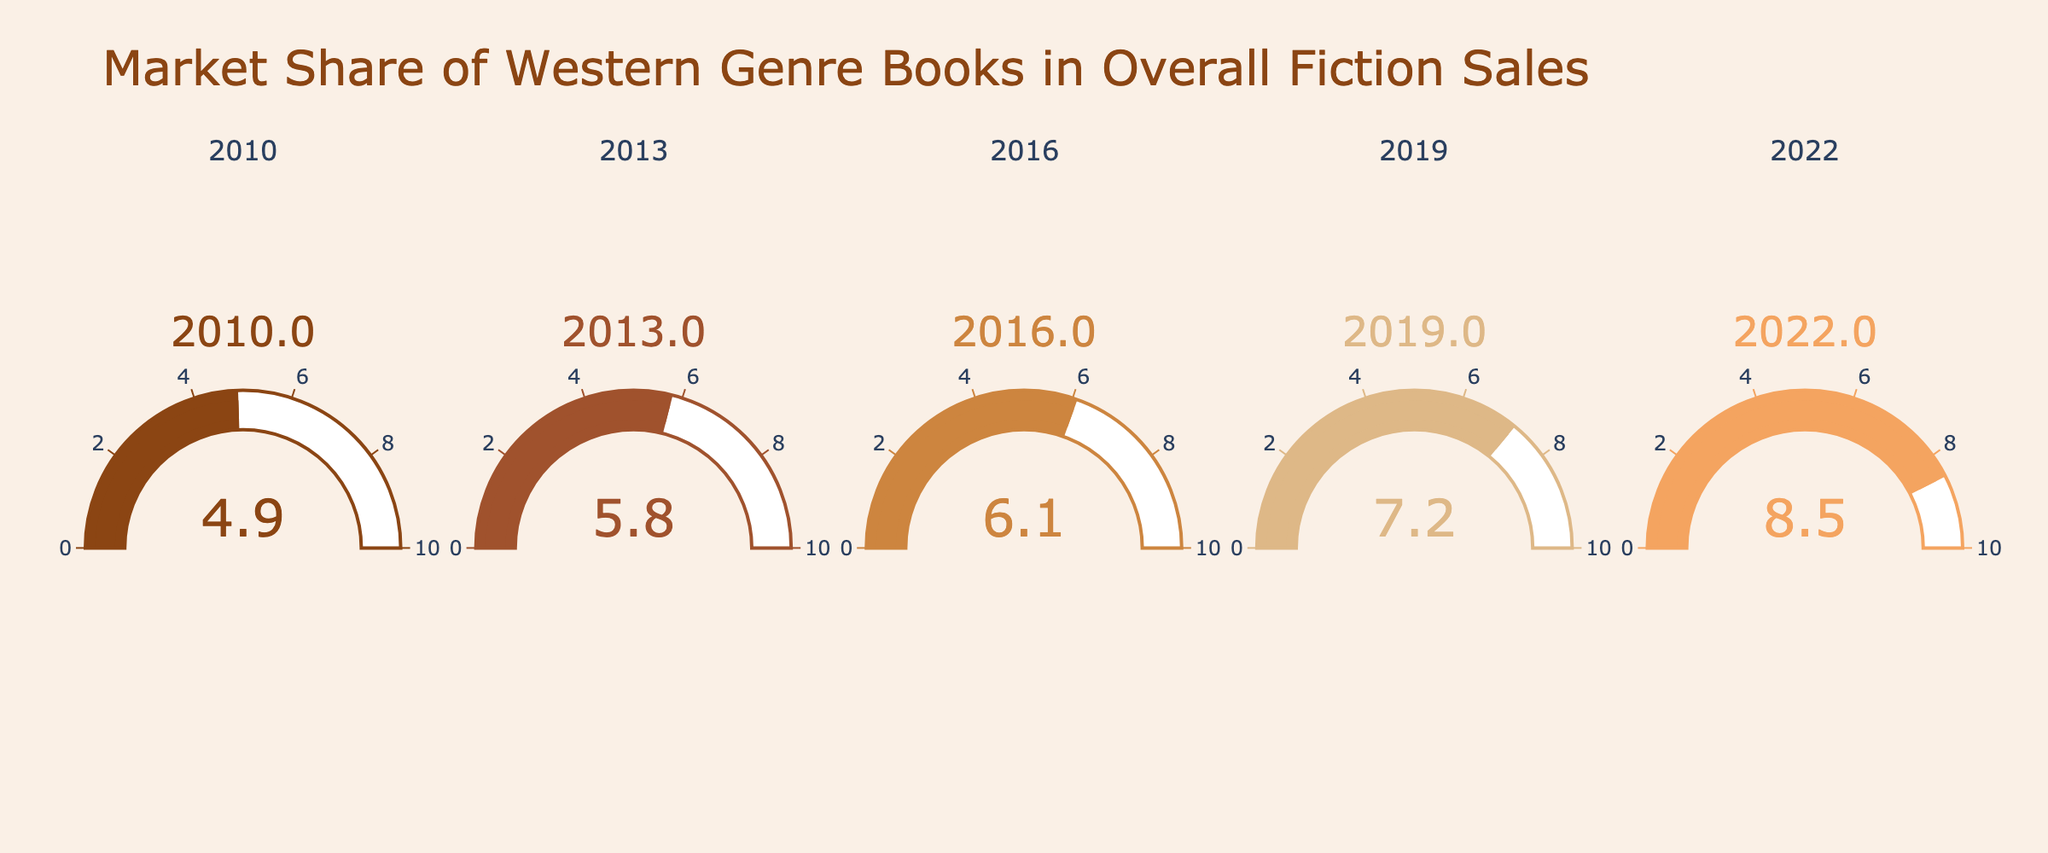What's the title of the figure? The title is prominently displayed at the top of the figure.
Answer: Market Share of Western Genre Books in Overall Fiction Sales How many gauge charts are shown in the figure? Count the number of subplots, each of which contains a gauge chart.
Answer: 5 What is the market share of Western genre books in 2022? Look at the gauge chart labeled 2022 and read the value.
Answer: 8.5 Which year shows the lowest market share for Western genre books? Compare the values on all gauge charts and identify the smallest one.
Answer: 2010 What is the difference in market share between the years 2022 and 2010? Subtract the market share in 2010 from the market share in 2022: 8.5 - 4.9.
Answer: 3.6 In which year did the market share of Western genre books see the largest increase compared to the previous data point? Identify the largest difference between consecutive years’ values: 
2010-2013: 5.8 - 4.9 = 0.9 
2013-2016: 6.1 - 5.8 = 0.3 
2016-2019: 7.2 - 6.1 = 1.1 
2019-2022: 8.5 - 7.2 = 1.3 
The largest increase happened between 2019 and 2022.
Answer: 2019 to 2022 What is the average market share of Western genre books from 2010 to 2022? Calculate the average by adding all the values and dividing by the number of years: (8.5 + 7.2 + 6.1 + 5.8 + 4.9) / 5 = 32.5 / 5.
Answer: 6.5 Which year had a market share closest to 6%? Identify the year whose market share value is nearest to 6%. Compare 2010: 4.9, 2013: 5.8, 2016: 6.1, 2019: 7.2, and 2022: 8.5. By comparing the absolute differences, 2016 is closest to 6%.
Answer: 2016 What is the median market share value from 2010 to 2022? Sort the market share values and find the middle one: 4.9, 5.8, 6.1, 7.2, 8.5. The middle value in this sorted list is 6.1.
Answer: 6.1 How did the market share trend of Western genre books change over the years? Observe the overall trend by comparing the values over time: Each year shows a gradual increase from 4.9 in 2010 to 8.5 in 2022.
Answer: Increasing trend 